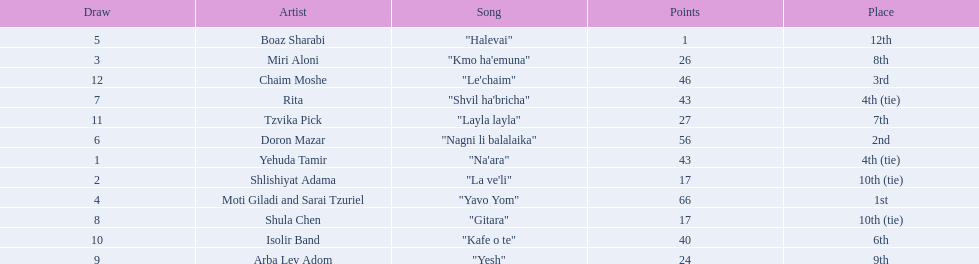Who were all the artists at the contest? Yehuda Tamir, Shlishiyat Adama, Miri Aloni, Moti Giladi and Sarai Tzuriel, Boaz Sharabi, Doron Mazar, Rita, Shula Chen, Arba Lev Adom, Isolir Band, Tzvika Pick, Chaim Moshe. What were their point totals? 43, 17, 26, 66, 1, 56, 43, 17, 24, 40, 27, 46. Of these, which is the least amount of points? 1. Which artists received this point total? Boaz Sharabi. 